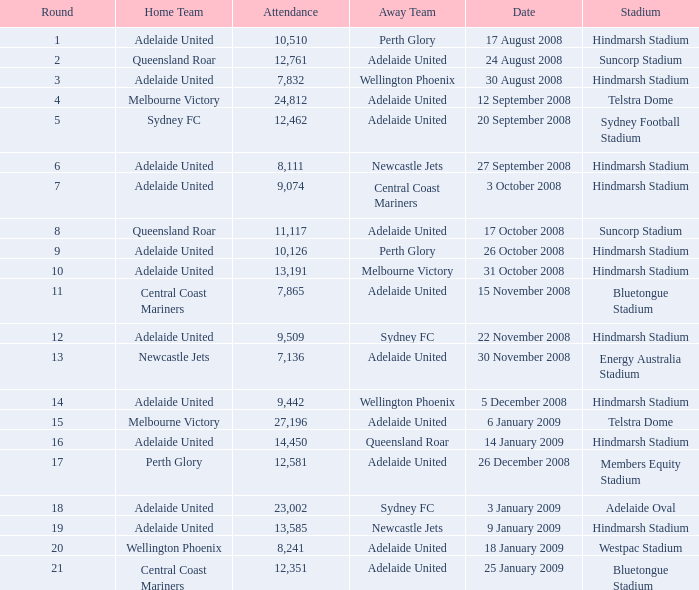Who was the away team when Queensland Roar was the home team in the round less than 3? Adelaide United. 